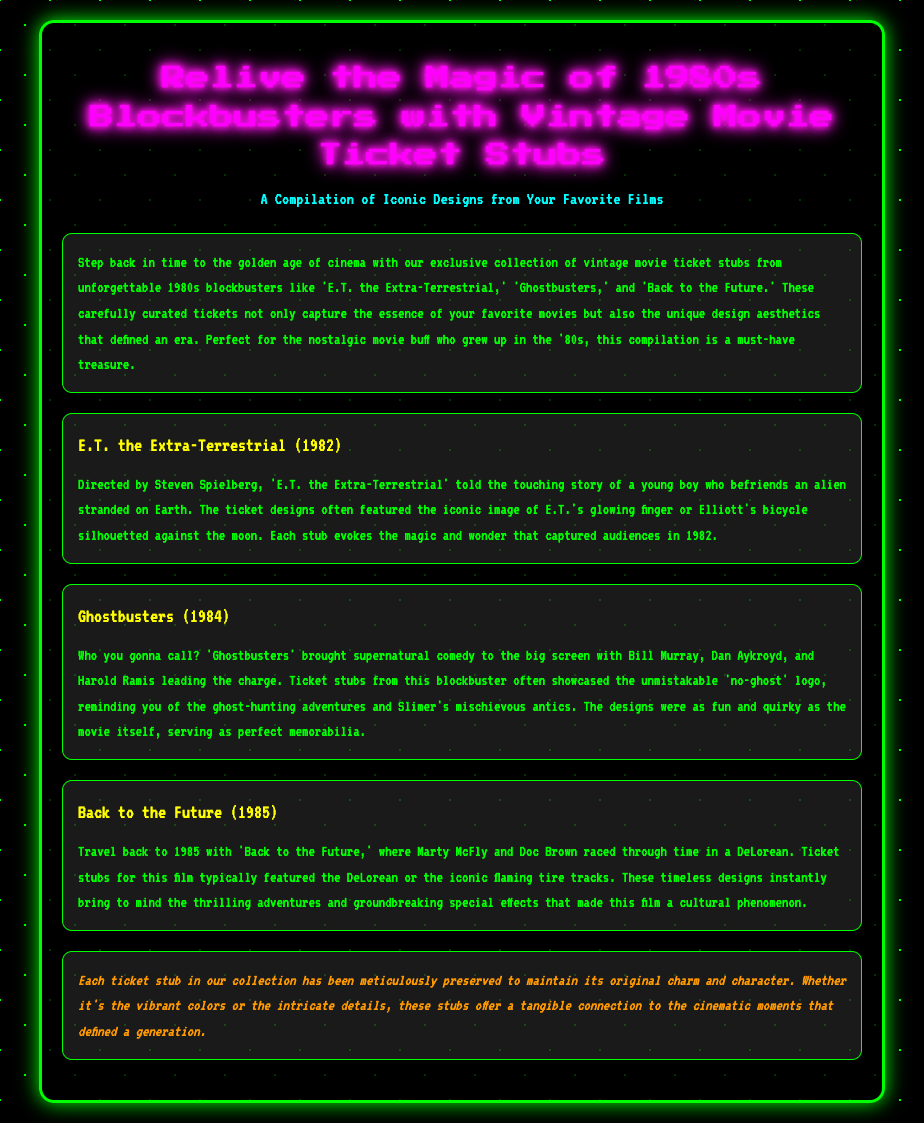what is the title of the document? The title of the document is stated in the `<title>` tag and reflects the focus on 1980s movie ticket stubs.
Answer: 80s Movie Ticket Stubs Collection who directed E.T. the Extra-Terrestrial? The document mentions Steven Spielberg as the director of E.T. the Extra-Terrestrial under the relevant section header.
Answer: Steven Spielberg in what year was Back to the Future released? The year of release for Back to the Future is mentioned explicitly in the section dedicated to that film.
Answer: 1985 what logo is often featured on Ghostbusters ticket stubs? The document specifies the 'no-ghost' logo as a common feature on ticket stubs for Ghostbusters.
Answer: no-ghost which film features a DeLorean? The section discussing Back to the Future states that it prominently features a DeLorean.
Answer: Back to the Future how were the ticket stubs preserved? The document notes that each ticket stub has been meticulously preserved to maintain its original charm and character.
Answer: meticulously what is the overall theme of the document? The introductory section encapsulates the overall theme of the document, which highlights the nostalgic movie ticket stubs from 1980s blockbusters.
Answer: nostalgia how many movies are specifically mentioned in the document? The document explicitly mentions three films in total in the corresponding sections.
Answer: three what color scheme is used for the document background? The background style of the document is described in the CSS as using black with green accents reflecting the nostalgic theme.
Answer: black and green 